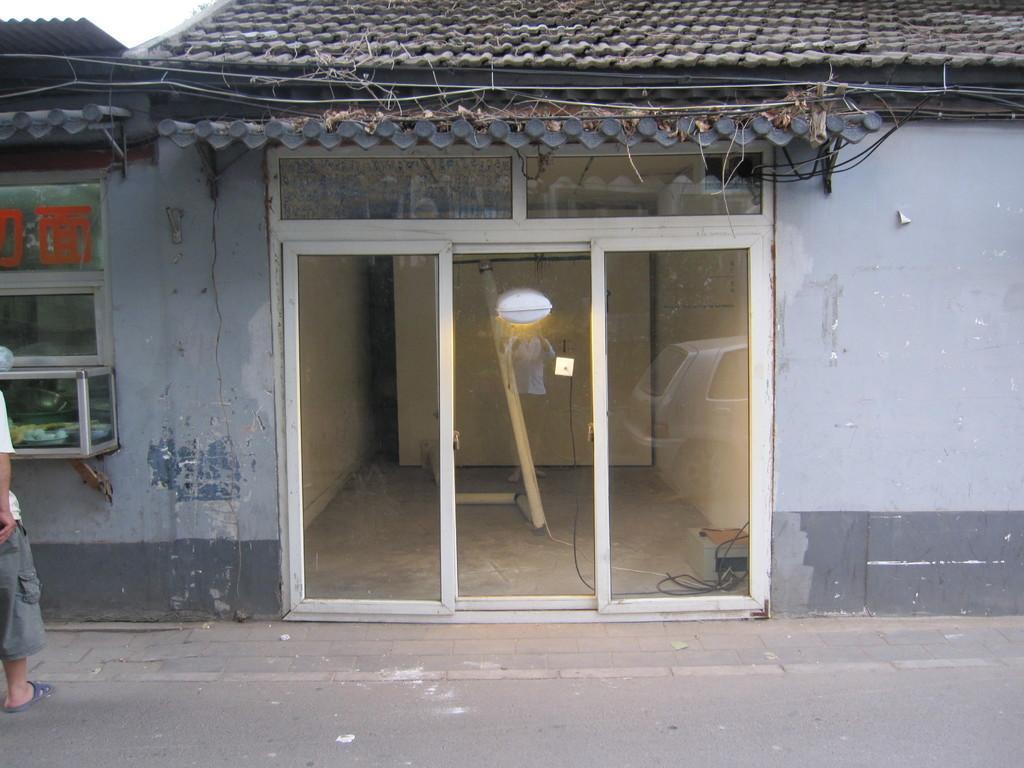Can you describe this image briefly? In this image in front there is a building. At the center of the image there is a glass window. In front of the building there is a person standing on the road. 